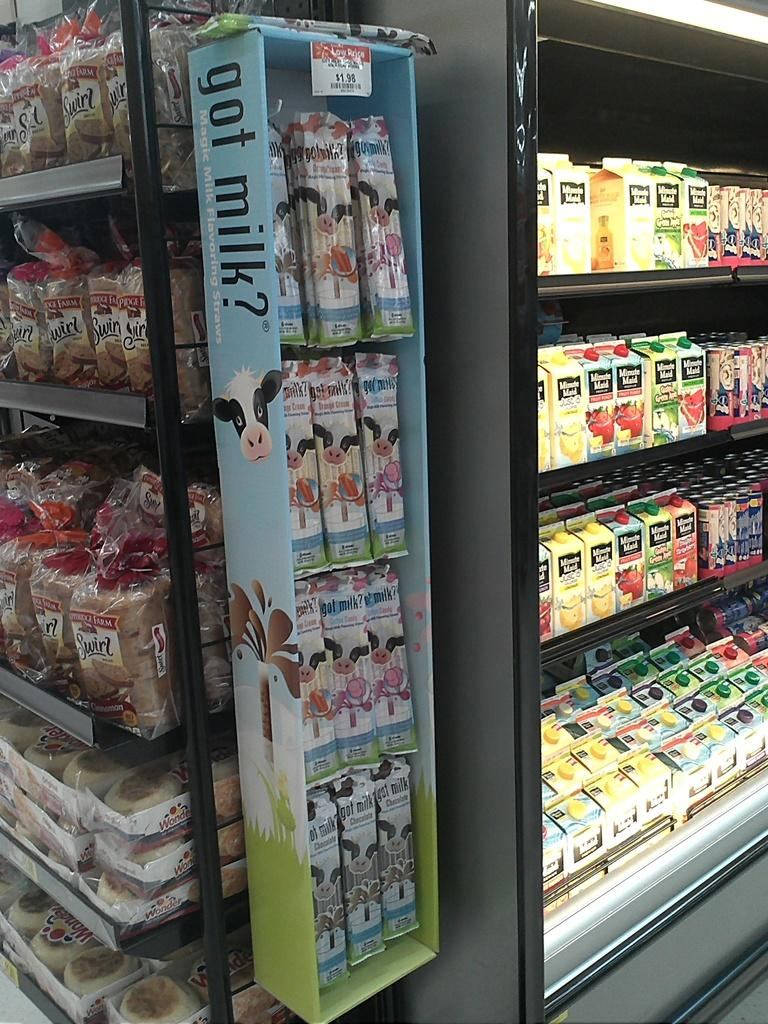<image>
Provide a brief description of the given image. A grocery isle with a display old cold beverages made by Minute Maid. 